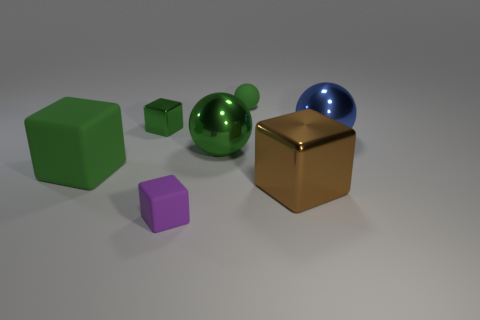There is a tiny sphere that is the same color as the large rubber object; what material is it?
Your response must be concise. Rubber. Is the color of the rubber ball the same as the tiny metal thing?
Offer a very short reply. Yes. Is the number of big matte cubes less than the number of rubber cubes?
Provide a succinct answer. Yes. What material is the big thing on the left side of the tiny green cube?
Offer a very short reply. Rubber. What material is the green cube that is the same size as the purple matte cube?
Offer a terse response. Metal. There is a green sphere to the left of the tiny matte thing that is right of the small block that is in front of the brown metallic thing; what is it made of?
Your answer should be very brief. Metal. There is a green matte thing right of the purple block; does it have the same size as the tiny green metallic block?
Offer a terse response. Yes. Is the number of large red metal cubes greater than the number of green shiny spheres?
Your response must be concise. No. How many tiny things are green metallic objects or matte balls?
Give a very brief answer. 2. How many other objects are the same color as the large matte thing?
Your answer should be compact. 3. 